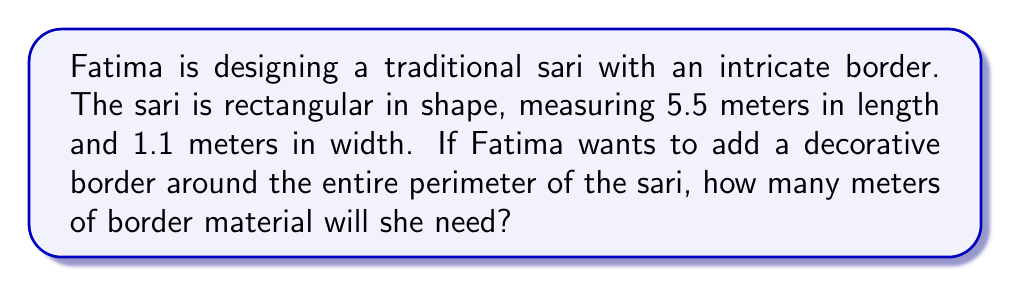Help me with this question. To solve this problem, we need to calculate the perimeter of the rectangular sari. The perimeter of a rectangle is the sum of all its sides. Let's break it down step by step:

1. Identify the dimensions:
   Length (l) = 5.5 meters
   Width (w) = 1.1 meters

2. Recall the formula for the perimeter of a rectangle:
   $$P = 2l + 2w$$
   Where P is the perimeter, l is the length, and w is the width.

3. Substitute the values into the formula:
   $$P = 2(5.5) + 2(1.1)$$

4. Simplify:
   $$P = 11 + 2.2$$

5. Calculate the final result:
   $$P = 13.2$$

Therefore, Fatima will need 13.2 meters of border material to decorate the entire perimeter of her sari.
Answer: $13.2$ meters 